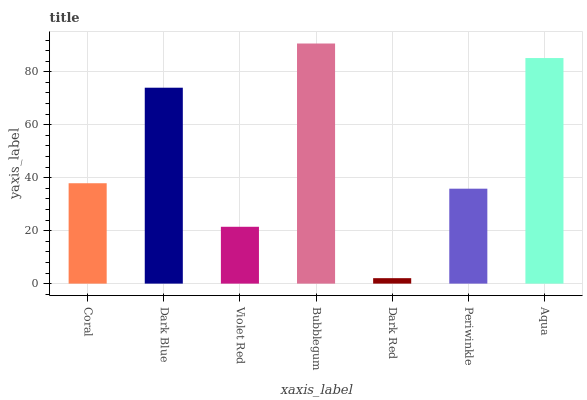Is Dark Red the minimum?
Answer yes or no. Yes. Is Bubblegum the maximum?
Answer yes or no. Yes. Is Dark Blue the minimum?
Answer yes or no. No. Is Dark Blue the maximum?
Answer yes or no. No. Is Dark Blue greater than Coral?
Answer yes or no. Yes. Is Coral less than Dark Blue?
Answer yes or no. Yes. Is Coral greater than Dark Blue?
Answer yes or no. No. Is Dark Blue less than Coral?
Answer yes or no. No. Is Coral the high median?
Answer yes or no. Yes. Is Coral the low median?
Answer yes or no. Yes. Is Bubblegum the high median?
Answer yes or no. No. Is Periwinkle the low median?
Answer yes or no. No. 